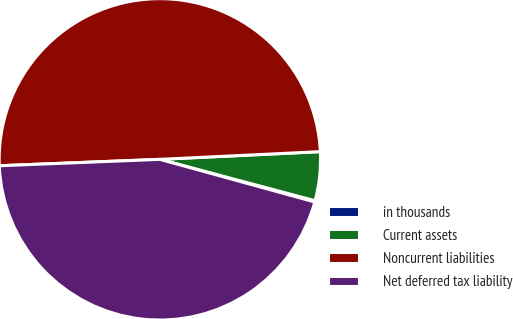<chart> <loc_0><loc_0><loc_500><loc_500><pie_chart><fcel>in thousands<fcel>Current assets<fcel>Noncurrent liabilities<fcel>Net deferred tax liability<nl><fcel>0.13%<fcel>4.91%<fcel>49.87%<fcel>45.09%<nl></chart> 